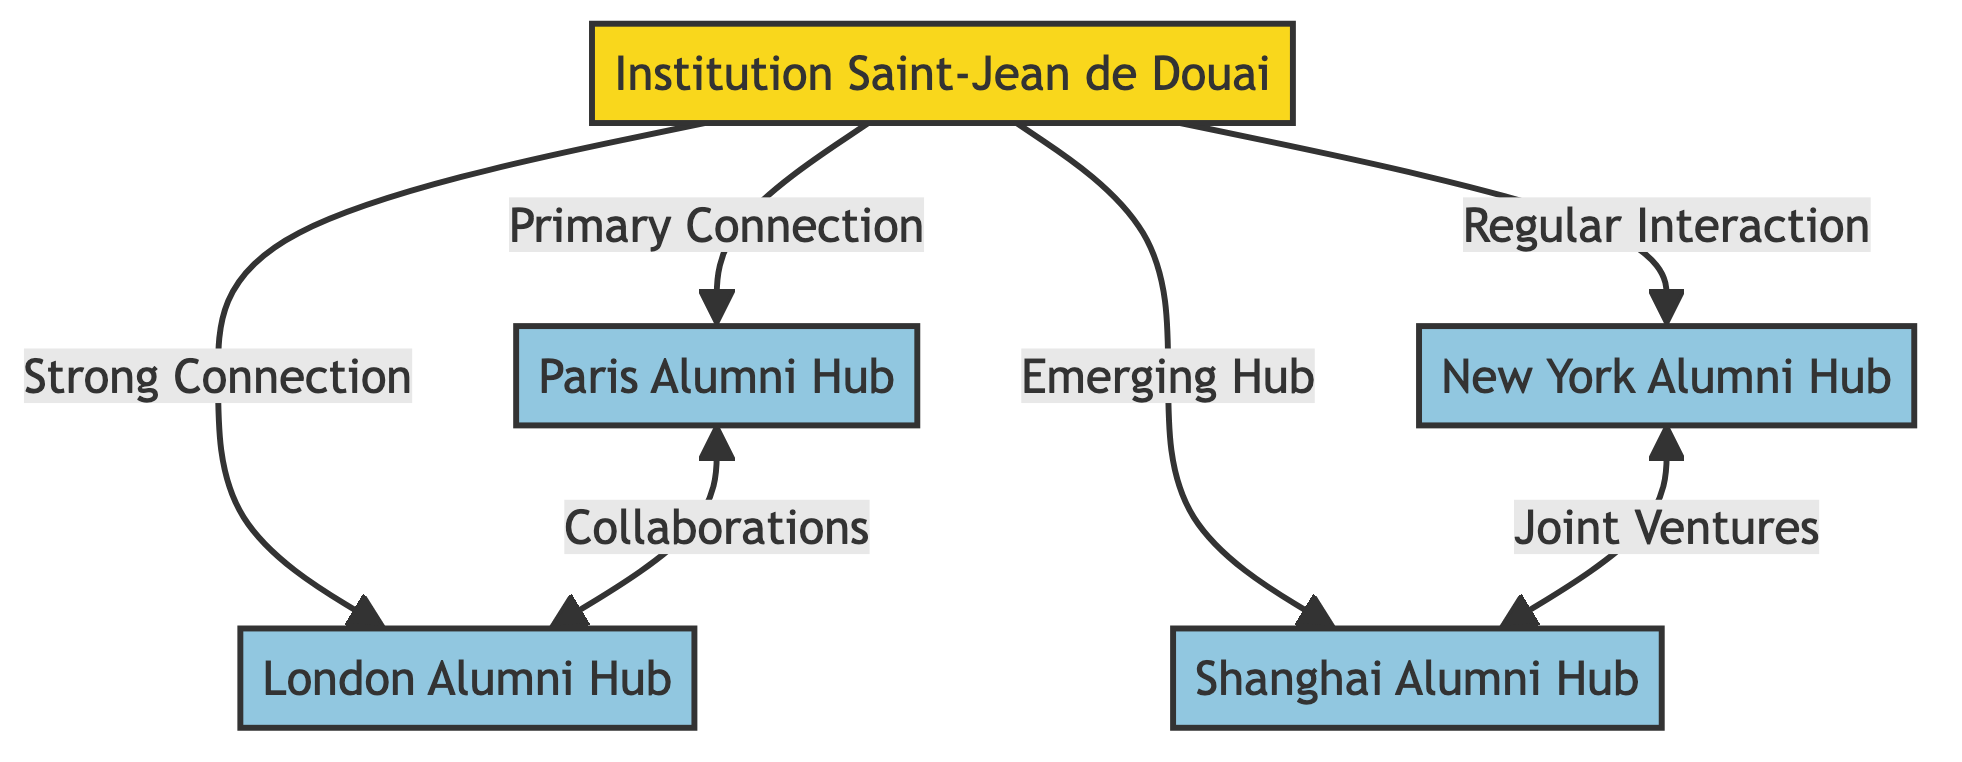What is the primary connection of the Institution Saint-Jean de Douai? In the diagram, the arrow connecting the Institution Saint-Jean de Douai to the Paris Alumni Hub is labeled "Primary Connection". This indicates the most significant relationship.
Answer: Paris Alumni Hub How many alumni hubs are connected to the Institution Saint-Jean de Douai? By counting the hubs shown in the diagram, there are four connections leading from the Institution Saint-Jean de Douai to various hubs.
Answer: Four Which hub has a strong connection to the Institution Saint-Jean de Douai? The connection labeled "Strong Connection" in the diagram directly points from the Institution Saint-Jean de Douai to the London Alumni Hub.
Answer: London Alumni Hub What type of interaction exists between the New York Alumni Hub and the Shanghai Alumni Hub? The diagram indicates a "Joint Ventures" connection between the New York Alumni Hub and the Shanghai Alumni Hub, showing the nature of their interaction.
Answer: Joint Ventures How many collaborations exist between the Paris Alumni Hub and the London Alumni Hub? The diagram shows a double-headed arrow labeled "Collaborations" connecting the Paris Alumni Hub and the London Alumni Hub, indicating a mutual relationship.
Answer: One 